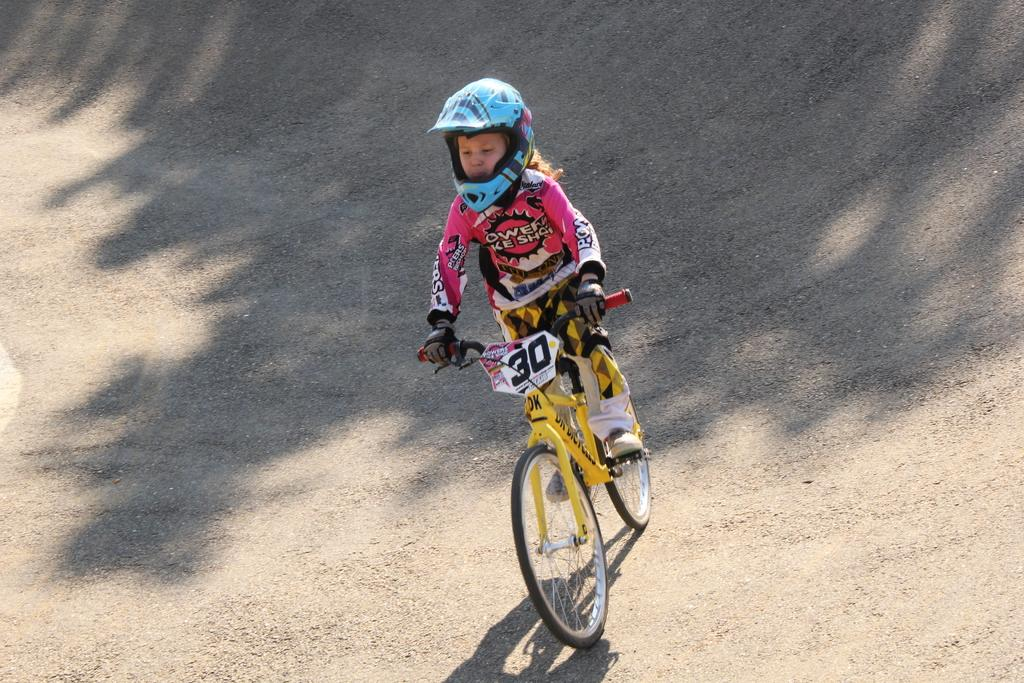What is the main subject of the image? The main subject of the image is a kid. What is the kid doing in the image? The kid is riding a bicycle in the image. What can be seen beneath the kid and bicycle? The ground is visible in the image. Are there any additional details visible on the ground? Yes, there are shadows on the ground in the image. What type of hearing aid is the kid wearing in the image? There is no hearing aid visible in the image; the kid is riding a bicycle. What offer is being made by the kid in the image? There is no offer being made by the kid in the image; the kid is simply riding a bicycle. 